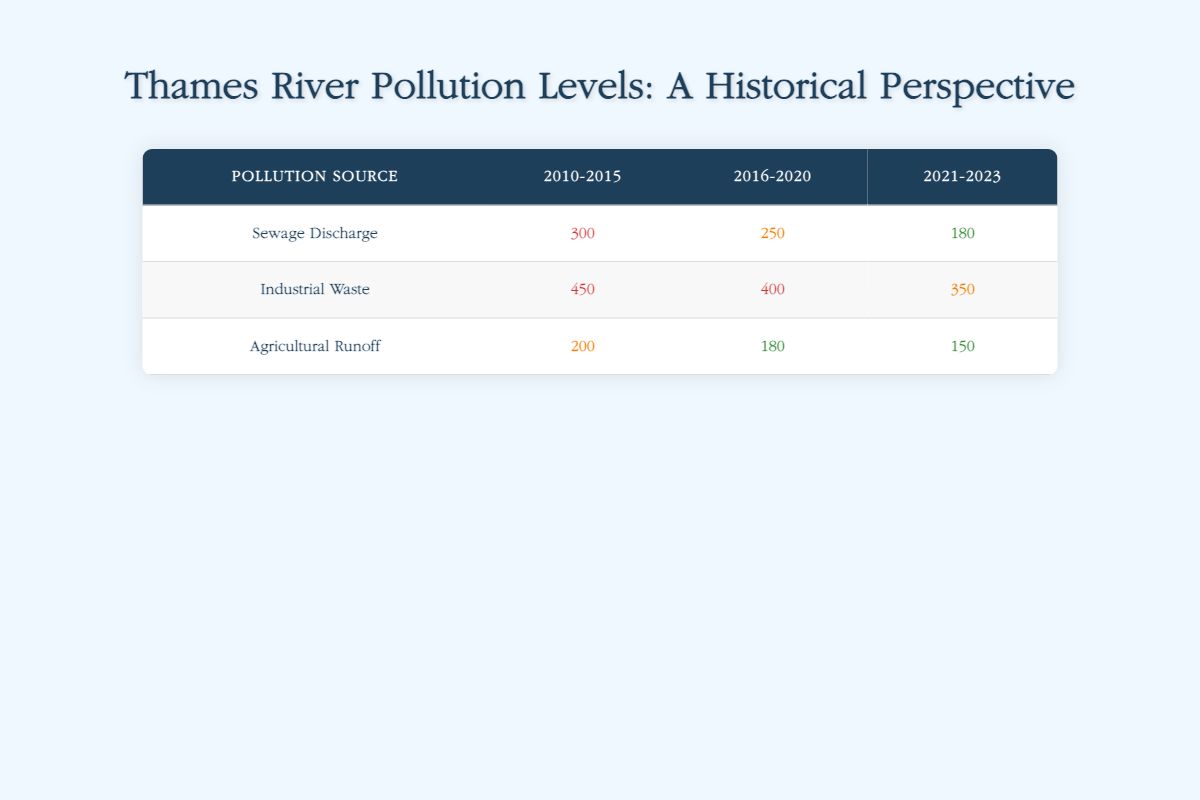What is the pollution level from Industrial Waste in 2010-2015? The table lists the pollution level for Industrial Waste in the time period of 2010-2015 as 450.
Answer: 450 What was the highest pollution level recorded in the table? The highest pollution level recorded in the table is 450, which comes from Industrial Waste during the period of 2010-2015.
Answer: 450 How much did the pollution level from Agricultural Runoff decrease from 2010-2015 to 2021-2023? The pollution level for Agricultural Runoff in 2010-2015 was 200, and it decreased to 150 by 2021-2023. The decrease is calculated as 200 - 150 = 50.
Answer: 50 Is the pollution level from Sewage Discharge higher in 2010-2015 than in 2021-2023? The pollution level from Sewage Discharge in 2010-2015 is 300, while in 2021-2023 it is 180. Since 300 is greater than 180, the statement is true.
Answer: Yes What is the average pollution level for Industrial Waste over all the given time periods? To find the average, we sum the pollution levels for Industrial Waste: 450 (2010-2015) + 400 (2016-2020) + 350 (2021-2023) = 1200. Then, we divide by the number of periods (3): 1200 / 3 = 400.
Answer: 400 What was the pollution level from Agricultural Runoff during the period 2016-2020? The table shows that the pollution level from Agricultural Runoff during 2016-2020 is 180.
Answer: 180 Did the pollution level from Sewage Discharge increase from 2010-2015 to 2016-2020? The pollution level from Sewage Discharge decreased from 300 in 2010-2015 to 250 in 2016-2020, indicating it did not increase.
Answer: No What is the difference in pollution level from Industrial Waste between 2010-2015 and 2016-2020? The pollution level for Industrial Waste is 450 in 2010-2015 and 400 in 2016-2020. The difference is 450 - 400 = 50.
Answer: 50 